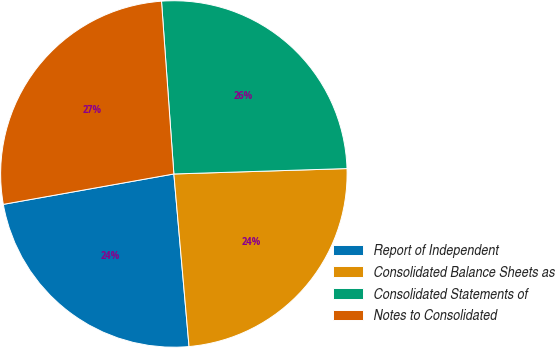Convert chart. <chart><loc_0><loc_0><loc_500><loc_500><pie_chart><fcel>Report of Independent<fcel>Consolidated Balance Sheets as<fcel>Consolidated Statements of<fcel>Notes to Consolidated<nl><fcel>23.59%<fcel>24.1%<fcel>25.64%<fcel>26.67%<nl></chart> 